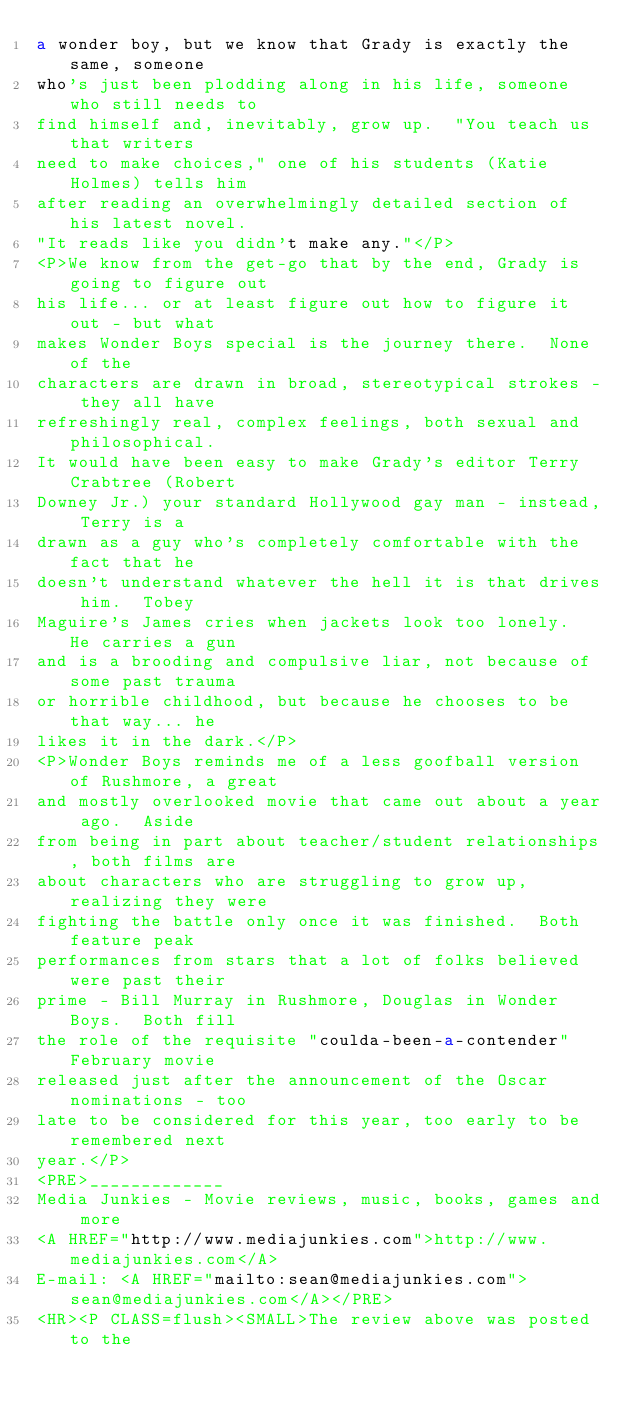Convert code to text. <code><loc_0><loc_0><loc_500><loc_500><_HTML_>a wonder boy, but we know that Grady is exactly the same, someone
who's just been plodding along in his life, someone who still needs to
find himself and, inevitably, grow up.  "You teach us that writers
need to make choices," one of his students (Katie Holmes) tells him
after reading an overwhelmingly detailed section of his latest novel.
"It reads like you didn't make any."</P>
<P>We know from the get-go that by the end, Grady is going to figure out
his life... or at least figure out how to figure it out - but what
makes Wonder Boys special is the journey there.  None of the
characters are drawn in broad, stereotypical strokes - they all have
refreshingly real, complex feelings, both sexual and philosophical.
It would have been easy to make Grady's editor Terry Crabtree (Robert
Downey Jr.) your standard Hollywood gay man - instead, Terry is a
drawn as a guy who's completely comfortable with the fact that he
doesn't understand whatever the hell it is that drives him.  Tobey
Maguire's James cries when jackets look too lonely.  He carries a gun
and is a brooding and compulsive liar, not because of some past trauma
or horrible childhood, but because he chooses to be that way... he
likes it in the dark.</P>
<P>Wonder Boys reminds me of a less goofball version of Rushmore, a great
and mostly overlooked movie that came out about a year ago.  Aside
from being in part about teacher/student relationships, both films are
about characters who are struggling to grow up, realizing they were
fighting the battle only once it was finished.  Both feature peak
performances from stars that a lot of folks believed were past their
prime - Bill Murray in Rushmore, Douglas in Wonder Boys.  Both fill
the role of the requisite "coulda-been-a-contender" February movie
released just after the announcement of the Oscar nominations - too
late to be considered for this year, too early to be remembered next
year.</P>
<PRE>_____________
Media Junkies - Movie reviews, music, books, games and more
<A HREF="http://www.mediajunkies.com">http://www.mediajunkies.com</A>
E-mail: <A HREF="mailto:sean@mediajunkies.com">sean@mediajunkies.com</A></PRE>
<HR><P CLASS=flush><SMALL>The review above was posted to the</code> 